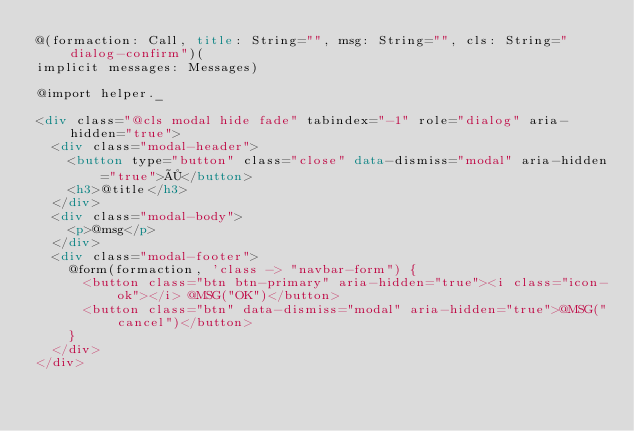Convert code to text. <code><loc_0><loc_0><loc_500><loc_500><_HTML_>@(formaction: Call, title: String="", msg: String="", cls: String="dialog-confirm")(
implicit messages: Messages)

@import helper._

<div class="@cls modal hide fade" tabindex="-1" role="dialog" aria-hidden="true">
  <div class="modal-header">
    <button type="button" class="close" data-dismiss="modal" aria-hidden="true">×</button>
    <h3>@title</h3>
  </div>
  <div class="modal-body">
    <p>@msg</p>
  </div>
  <div class="modal-footer">
    @form(formaction, 'class -> "navbar-form") {
      <button class="btn btn-primary" aria-hidden="true"><i class="icon-ok"></i> @MSG("OK")</button>
      <button class="btn" data-dismiss="modal" aria-hidden="true">@MSG("cancel")</button>
    }
  </div>
</div></code> 